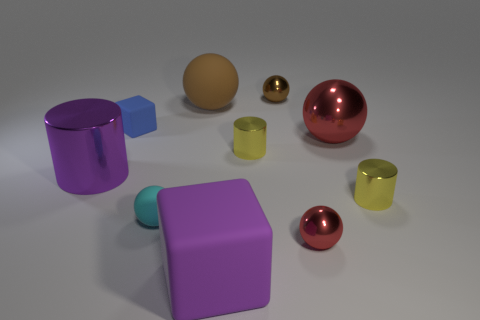Subtract all shiny spheres. How many spheres are left? 2 Subtract all purple cylinders. How many cylinders are left? 2 Subtract 2 balls. How many balls are left? 3 Add 5 tiny cyan things. How many tiny cyan things are left? 6 Add 6 small red metallic spheres. How many small red metallic spheres exist? 7 Subtract 1 purple blocks. How many objects are left? 9 Subtract all blocks. How many objects are left? 8 Subtract all purple cubes. Subtract all cyan spheres. How many cubes are left? 1 Subtract all green balls. How many blue cubes are left? 1 Subtract all green shiny things. Subtract all tiny red things. How many objects are left? 9 